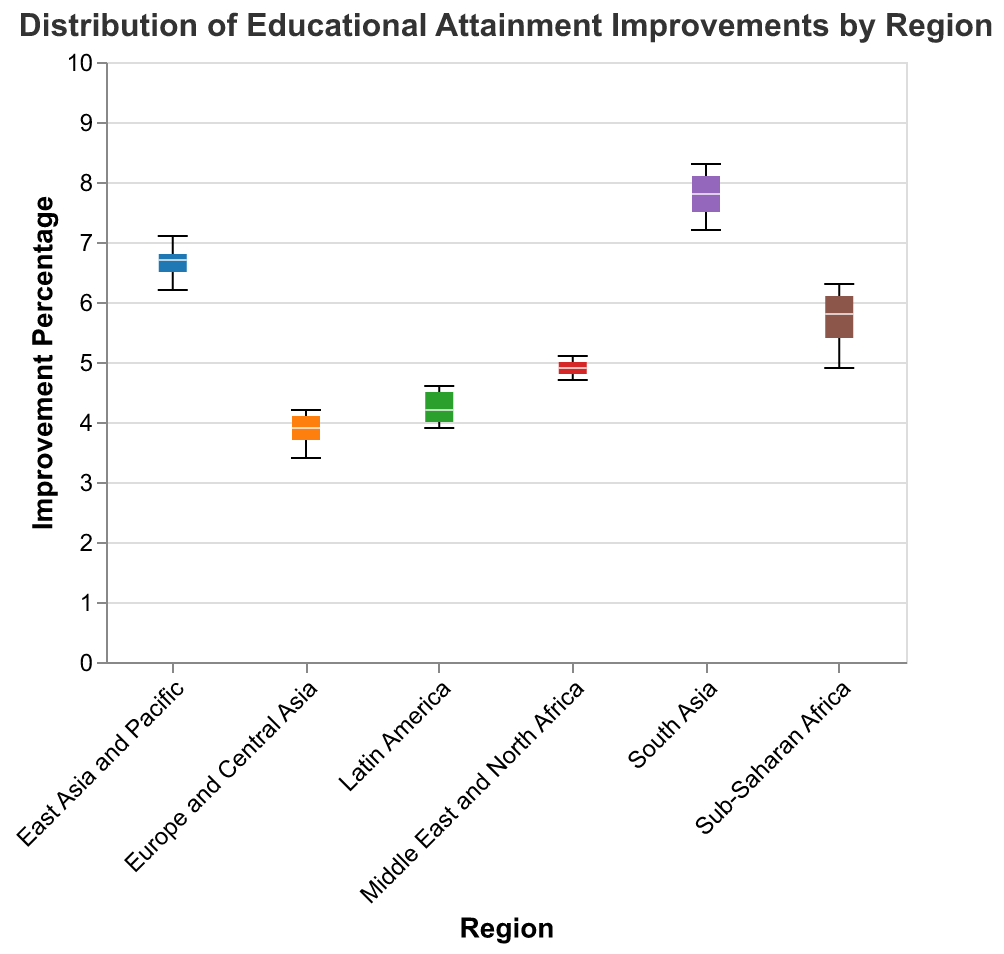What is the title of the chart? The title is placed at the top of the chart, specifying what the chart represents. It reads "Distribution of Educational Attainment Improvements by Region."
Answer: Distribution of Educational Attainment Improvements by Region Which region has the highest median improvement percentage? The notched box for South Asia shows the highest position on the y-axis for the median line compared to other regions.
Answer: South Asia What is the approximate range of improvement percentages for Europe and Central Asia? The notched box plot for Europe and Central Asia spans from slightly below 3.5 to about 4.2 on the y-axis.
Answer: 3.4 to 4.2 How does the median improvement percentage for East Asia and Pacific compare to that of Latin America? The median line within the box for East Asia and Pacific is higher on the y-axis than that for Latin America, indicating a higher median improvement percentage for East Asia and Pacific.
Answer: Higher Which regions have overlapping notches, signifying that their medians are not significantly different? Notched box plots with overlapping notches include Europe and Central Asia and Latin America, and Middle East and North Africa and Latin America.
Answer: Europe and Central Asia and Latin America, Middle East and North Africa and Latin America What is the median improvement percentage for the Sub-Saharan Africa region? The median line within the box plot for Sub-Saharan Africa is located approximately at 5.8 on the y-axis.
Answer: 5.8 Which region has the smallest interquartile range (IQR)? By observing the width of the boxes, Europe and Central Asia have the smallest IQR, as the box is the narrowest compared to other regions.
Answer: Europe and Central Asia Is the improvement percentage for South Asia generally higher than that for Middle East and North Africa? South Asia's notched box plots are positioned higher on the y-axis compared to Middle East and North Africa, showing a generally higher set of improvement percentages.
Answer: Yes Which region shows the greatest variability in improvement percentages? The widest box in the plot, representing the greatest variability in improvement percentages, belongs to South Asia.
Answer: South Asia 